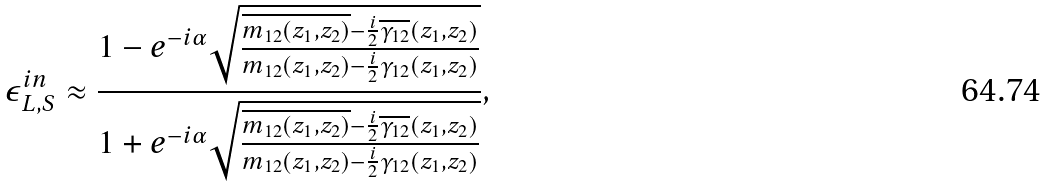<formula> <loc_0><loc_0><loc_500><loc_500>\epsilon _ { L , S } ^ { i n } \approx \frac { 1 - e ^ { - i \alpha } \sqrt { \frac { \overline { m _ { 1 2 } ( z _ { 1 } , z _ { 2 } ) } - \frac { i } { 2 } \overline { \gamma _ { 1 2 } } ( z _ { 1 } , z _ { 2 } ) } { m _ { 1 2 } ( z _ { 1 } , z _ { 2 } ) - \frac { i } { 2 } \gamma _ { 1 2 } ( z _ { 1 } , z _ { 2 } ) } } } { 1 + e ^ { - i \alpha } \sqrt { \frac { \overline { m _ { 1 2 } ( z _ { 1 } , z _ { 2 } ) } - \frac { i } { 2 } \overline { \gamma _ { 1 2 } } ( z _ { 1 } , z _ { 2 } ) } { m _ { 1 2 } ( z _ { 1 } , z _ { 2 } ) - \frac { i } { 2 } \gamma _ { 1 2 } ( z _ { 1 } , z _ { 2 } ) } } } ,</formula> 